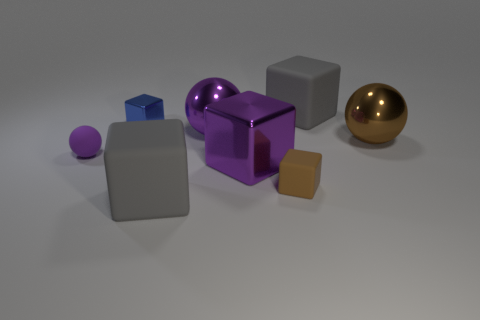What is the color of the other tiny rubber object that is the same shape as the small blue object?
Your answer should be compact. Brown. Are there fewer cyan rubber cylinders than purple metal spheres?
Your response must be concise. Yes. Is the small purple rubber object the same shape as the blue thing?
Your response must be concise. No. How many objects are either tiny metal blocks or brown matte objects in front of the tiny rubber ball?
Make the answer very short. 2. How many small blue metal objects are there?
Provide a succinct answer. 1. Are there any rubber cubes that have the same size as the purple matte thing?
Ensure brevity in your answer.  Yes. Is the number of large purple balls on the left side of the small purple ball less than the number of rubber blocks?
Provide a succinct answer. Yes. Do the purple metal cube and the brown shiny ball have the same size?
Provide a succinct answer. Yes. There is a purple sphere that is the same material as the brown cube; what is its size?
Offer a terse response. Small. What number of big rubber objects have the same color as the tiny matte ball?
Offer a terse response. 0. 